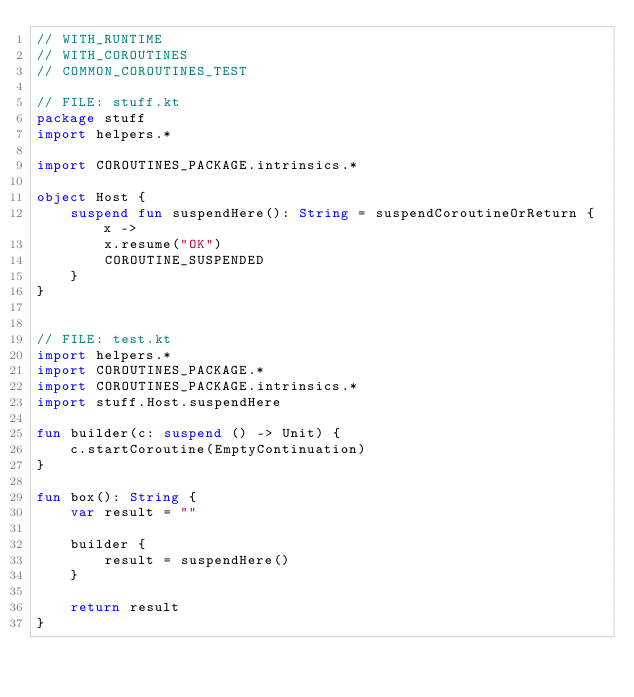Convert code to text. <code><loc_0><loc_0><loc_500><loc_500><_Kotlin_>// WITH_RUNTIME
// WITH_COROUTINES
// COMMON_COROUTINES_TEST

// FILE: stuff.kt
package stuff
import helpers.*

import COROUTINES_PACKAGE.intrinsics.*

object Host {
    suspend fun suspendHere(): String = suspendCoroutineOrReturn { x ->
        x.resume("OK")
        COROUTINE_SUSPENDED
    }
}


// FILE: test.kt
import helpers.*
import COROUTINES_PACKAGE.*
import COROUTINES_PACKAGE.intrinsics.*
import stuff.Host.suspendHere

fun builder(c: suspend () -> Unit) {
    c.startCoroutine(EmptyContinuation)
}

fun box(): String {
    var result = ""

    builder {
        result = suspendHere()
    }

    return result
}
</code> 